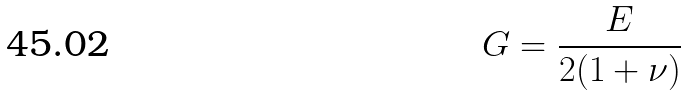<formula> <loc_0><loc_0><loc_500><loc_500>G = \frac { E } { 2 ( 1 + \nu ) }</formula> 